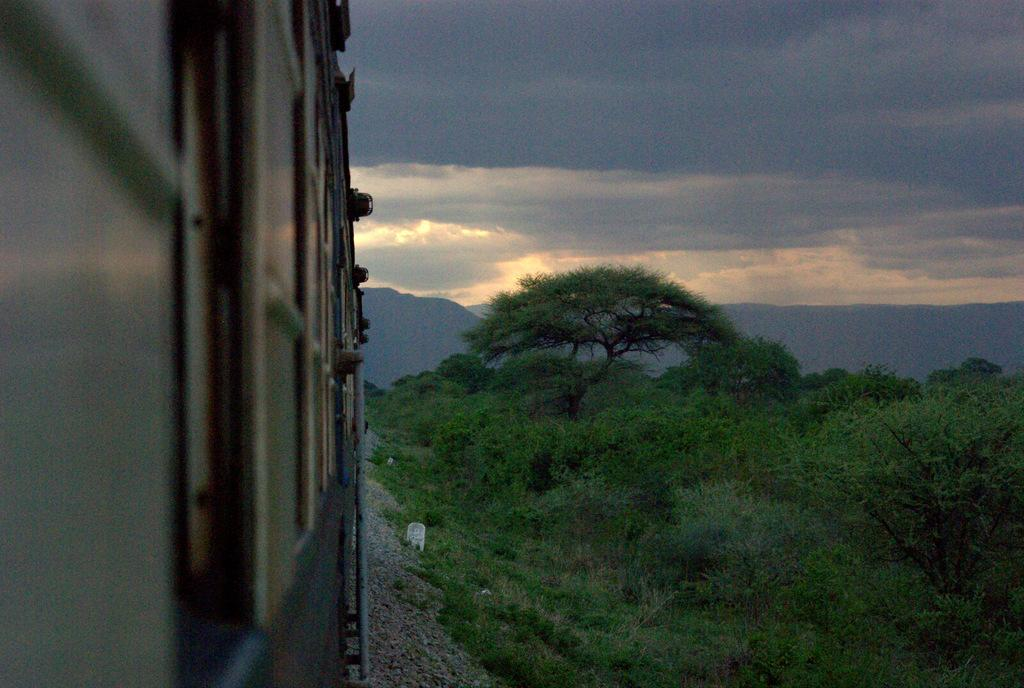What is the main subject of the image? There is a train in the image. What type of terrain can be seen in the image? There are stones, plants, grass, and trees visible in the image. What type of landscape is visible in the image? The hills are visible in the image. What is the condition of the sky in the image? The sky is cloudy in the image. What type of shock can be seen affecting the train in the image? There is no shock affecting the train in the image; it appears to be stationary. What type of quill is being used by the plants in the image? There are no quills present in the image; the plants are not using any writing instruments. 